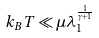<formula> <loc_0><loc_0><loc_500><loc_500>k _ { B } T \ll \mu \lambda _ { 1 } ^ { \frac { 1 } { \gamma + 1 } }</formula> 